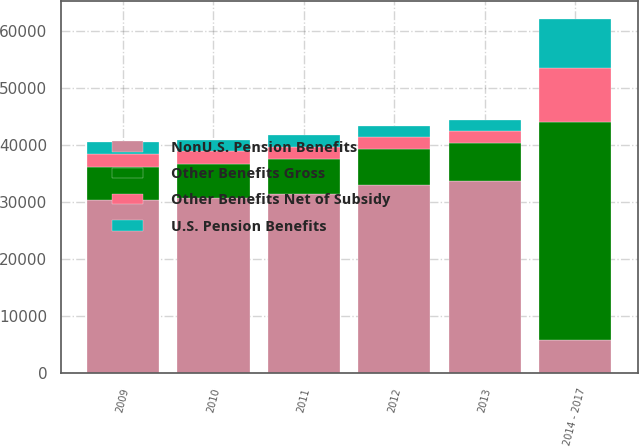Convert chart. <chart><loc_0><loc_0><loc_500><loc_500><stacked_bar_chart><ecel><fcel>2009<fcel>2010<fcel>2011<fcel>2012<fcel>2013<fcel>2014 - 2017<nl><fcel>Other Benefits Gross<fcel>5788<fcel>5891<fcel>6119<fcel>6365<fcel>6725<fcel>38118<nl><fcel>NonU.S. Pension Benefits<fcel>30432<fcel>30782<fcel>31390<fcel>32920<fcel>33650<fcel>5891<nl><fcel>Other Benefits Net of Subsidy<fcel>2197<fcel>2205<fcel>2183<fcel>2142<fcel>2069<fcel>9435<nl><fcel>U.S. Pension Benefits<fcel>2039<fcel>2039<fcel>2013<fcel>1969<fcel>1896<fcel>8648<nl></chart> 